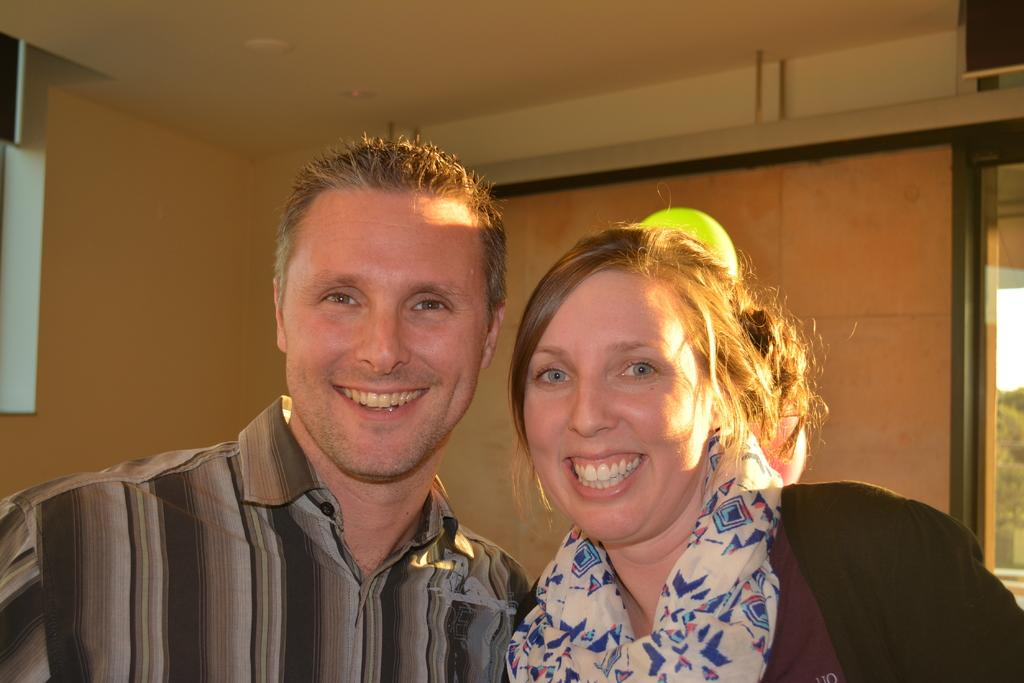What is the person in the image wearing? The person in the image is wearing a shirt. Can you describe the woman's attire in the image? The woman in the image is wearing a scarf. What can be seen in the background of the image? There is a wall with a window in the background of the image. What is visible through the window in the image? Trees are visible through the window in the image. How many thumbs can be seen on the person wearing a shirt in the image? There is no visible thumb on the person wearing a shirt in the image. Are there any deer visible in the image? There are no deer present in the image; only a person, a woman, a wall, a window, and trees are visible. 